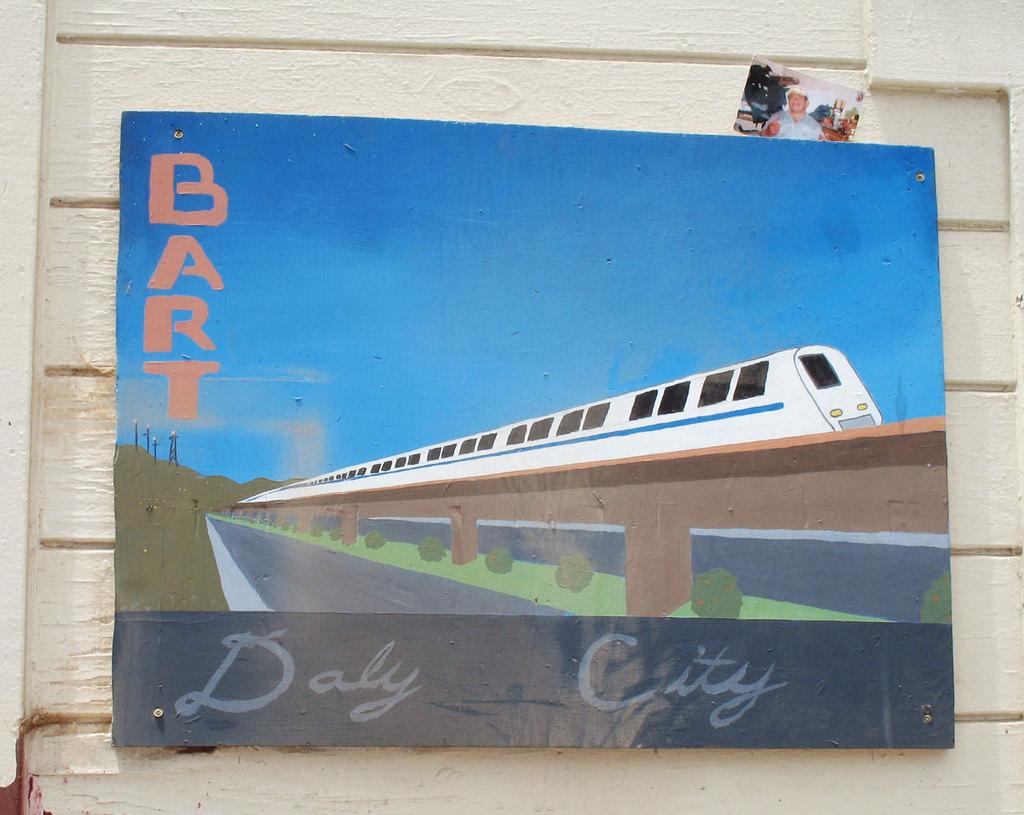What is attached to the wall in the image? The image contains a board fixed to a wall. What is depicted on the board? There is a picture of a train on the board. What type of vegetation can be seen in the image? Bushes are visible in the image. What geographical feature is present in the image? There is a hill in the image. What else is featured on the board besides the picture of the train? There are letters on the board. How was the image captured? The image appears to be a photograph. What is the father's name in the image? There is no person or father present in the image; it features a board with a picture of a train, letters, and a photographic setting. What is the tendency of the minute hand in the image? There is no clock or time-related element present in the image, so it is not possible to determine the movement of a minute hand. 